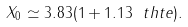<formula> <loc_0><loc_0><loc_500><loc_500>X _ { 0 } \simeq 3 . 8 3 ( 1 + 1 . 1 3 \ t h t e ) .</formula> 